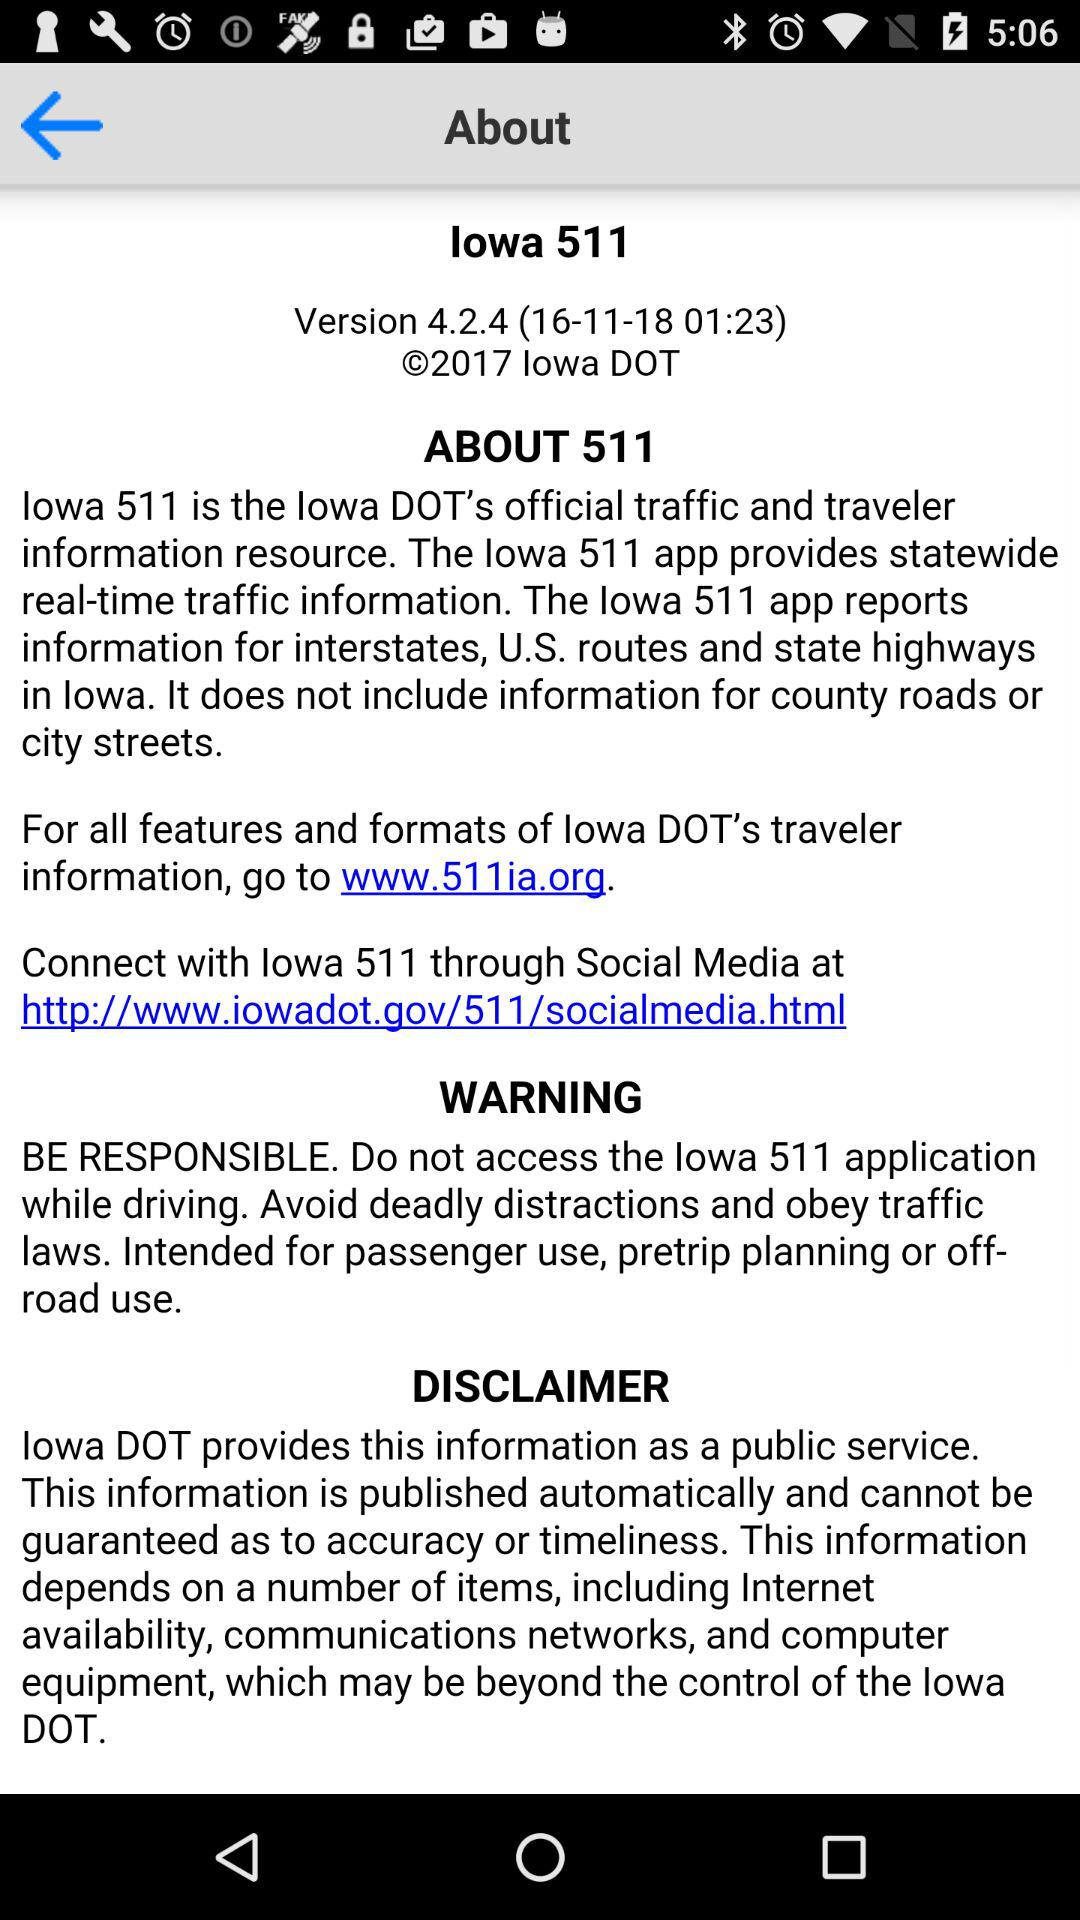What is the release year of the version? The release year of the version is 2018. 